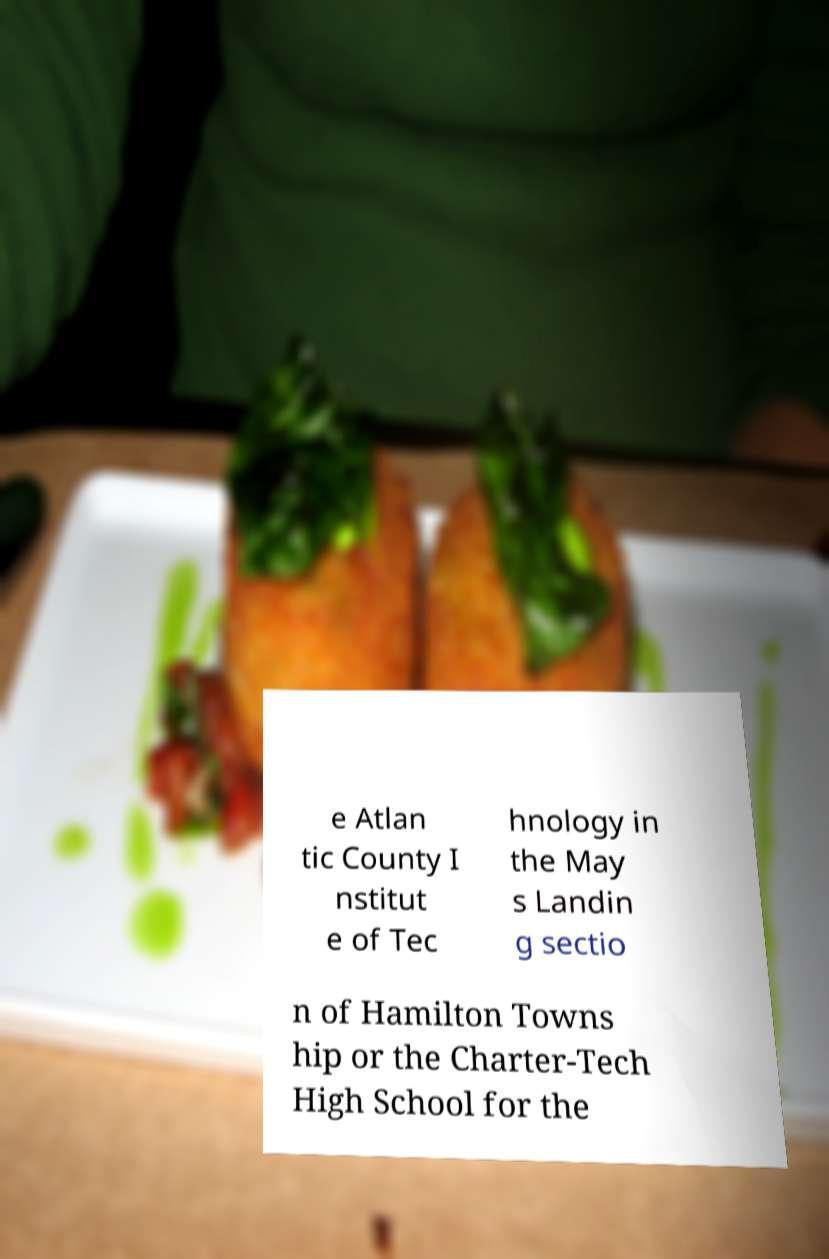Can you read and provide the text displayed in the image?This photo seems to have some interesting text. Can you extract and type it out for me? e Atlan tic County I nstitut e of Tec hnology in the May s Landin g sectio n of Hamilton Towns hip or the Charter-Tech High School for the 